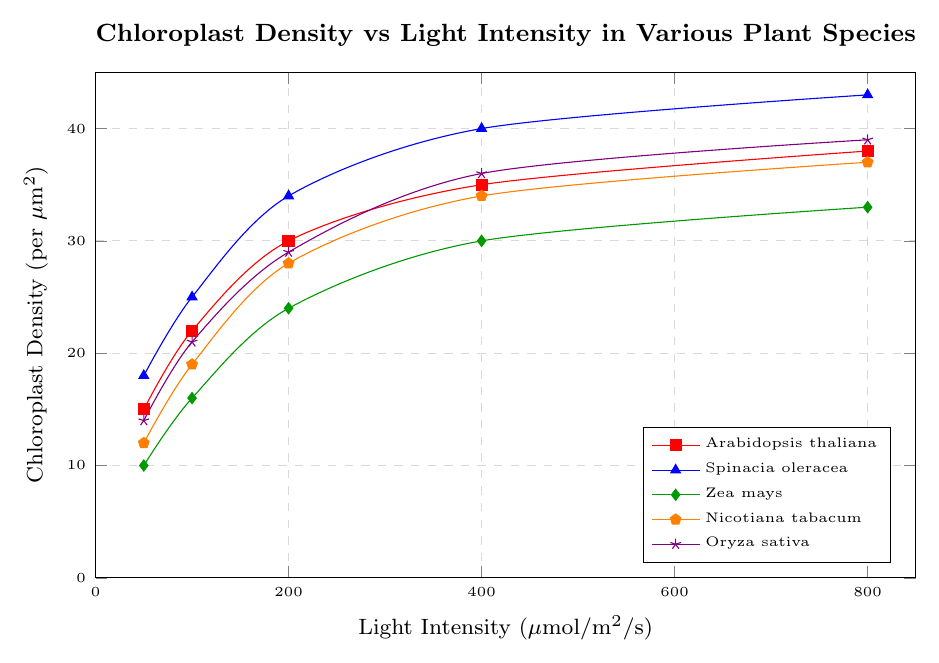what is the chloroplast density of Nicotiana tabacum at a light intensity of 200 µmol/m²/s? To find the chloroplast density of Nicotiana tabacum at a light intensity of 200 µmol/m²/s, locate the corresponding value on the graph where the Nicotiana tabacum data line intersects the 200 µmol/m²/s point. It shows a density of 28 per µm².
Answer: 28 per µm² Which plant species shows the highest chloroplast density at 800 µmol/m²/s? To identify the plant species with the highest chloroplast density at 800 µmol/m²/s, compare the chloroplast densities of all species at this light intensity. Spinacia oleracea has a density of 43 per µm², which is the highest.
Answer: Spinacia oleracea Does Arabidopsis thaliana or Zea mays have a higher chloroplast density at 400 µmol/m²/s? Compare the chloroplast densities of Arabidopsis thaliana and Zea mays at 400 µmol/m²/s on the graph. Arabidopsis thaliana has a density of 35 per µm², while Zea mays has a density of 30 per µm². Arabidopsis thaliana has the higher density.
Answer: Arabidopsis thaliana What is the average chloroplast density of Oryza sativa at light intensities of 50, 100, and 200 µmol/m²/s? To find the average chloroplast density, sum the densities of Oryza sativa at these intensities and divide by the number of points. (14 + 21 + 29) / 3 = 64 / 3 = 21.33 per µm².
Answer: 21.33 per µm² Which species has the smallest increase in chloroplast density from 50 µmol/m²/s to 100 µmol/m²/s? Calculate the increase in chloroplast density for each species from 50 to 100 µmol/m²/s. Arabidopsis thaliana: 22 - 15 = 7, Spinacia oleracea: 25 - 18 = 7, Zea mays: 16 - 10 = 6, Nicotiana tabacum: 19 - 12 = 7, Oryza sativa: 21 - 14 = 7. Zea mays has the smallest increase.
Answer: Zea mays What is the difference in chloroplast density between Arabidopsis thaliana and Oryza sativa at 800 µmol/m²/s? Find the chloroplast densities of both species at 800 µmol/m²/s and subtract the smaller from the larger: 39 (Oryza sativa) - 38 (Arabidopsis thaliana) = 1 per µm².
Answer: 1 per µm² Rank the plant species by their chloroplast density at 400 µmol/m²/s from highest to lowest. Compare the chloroplast densities of all plant species at 400 µmol/m²/s and then arrange them in descending order: Spinacia oleracea (40), Oryza sativa (36), Nicotiana tabacum (34), Arabidopsis thaliana (35), Zea mays (30). The order is: Spinacia oleracea > Oryza sativa > Arabidopsis thaliana > Nicotiana tabacum > Zea mays.
Answer: Spinacia oleracea, Oryza sativa, Arabidopsis thaliana, Nicotiana tabacum, Zea mays 